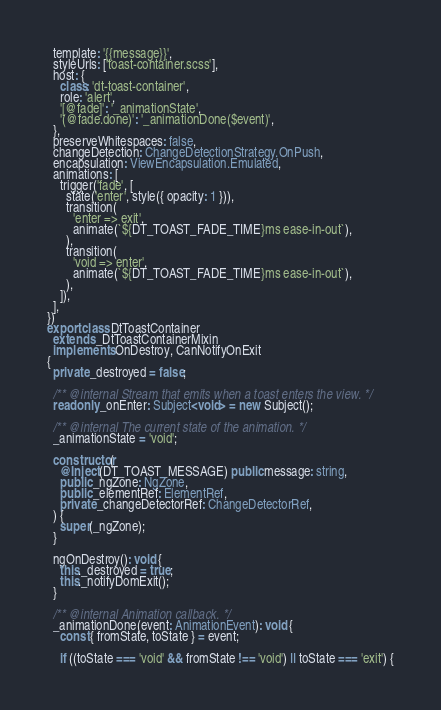<code> <loc_0><loc_0><loc_500><loc_500><_TypeScript_>  template: '{{message}}',
  styleUrls: ['toast-container.scss'],
  host: {
    class: 'dt-toast-container',
    role: 'alert',
    '[@fade]': '_animationState',
    '(@fade.done)': '_animationDone($event)',
  },
  preserveWhitespaces: false,
  changeDetection: ChangeDetectionStrategy.OnPush,
  encapsulation: ViewEncapsulation.Emulated,
  animations: [
    trigger('fade', [
      state('enter', style({ opacity: 1 })),
      transition(
        'enter => exit',
        animate(`${DT_TOAST_FADE_TIME}ms ease-in-out`),
      ),
      transition(
        'void => enter',
        animate(`${DT_TOAST_FADE_TIME}ms ease-in-out`),
      ),
    ]),
  ],
})
export class DtToastContainer
  extends _DtToastContainerMixin
  implements OnDestroy, CanNotifyOnExit
{
  private _destroyed = false;

  /** @internal Stream that emits when a toast enters the view. */
  readonly _onEnter: Subject<void> = new Subject();

  /** @internal The current state of the animation. */
  _animationState = 'void';

  constructor(
    @Inject(DT_TOAST_MESSAGE) public message: string,
    public _ngZone: NgZone,
    public _elementRef: ElementRef,
    private _changeDetectorRef: ChangeDetectorRef,
  ) {
    super(_ngZone);
  }

  ngOnDestroy(): void {
    this._destroyed = true;
    this._notifyDomExit();
  }

  /** @internal Animation callback. */
  _animationDone(event: AnimationEvent): void {
    const { fromState, toState } = event;

    if ((toState === 'void' && fromState !== 'void') || toState === 'exit') {</code> 